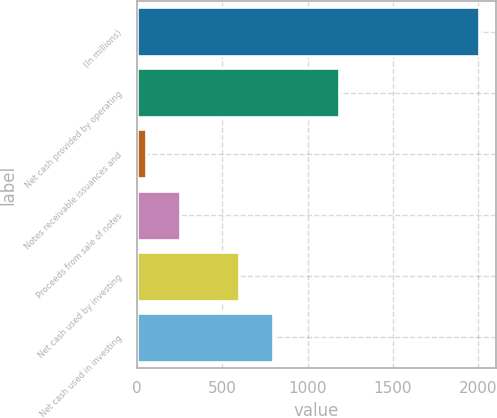Convert chart. <chart><loc_0><loc_0><loc_500><loc_500><bar_chart><fcel>(In millions)<fcel>Net cash provided by operating<fcel>Notes receivable issuances and<fcel>Proceeds from sale of notes<fcel>Net cash used by investing<fcel>Net cash used in investing<nl><fcel>2003<fcel>1185.36<fcel>54.8<fcel>249.62<fcel>600.9<fcel>795.72<nl></chart> 